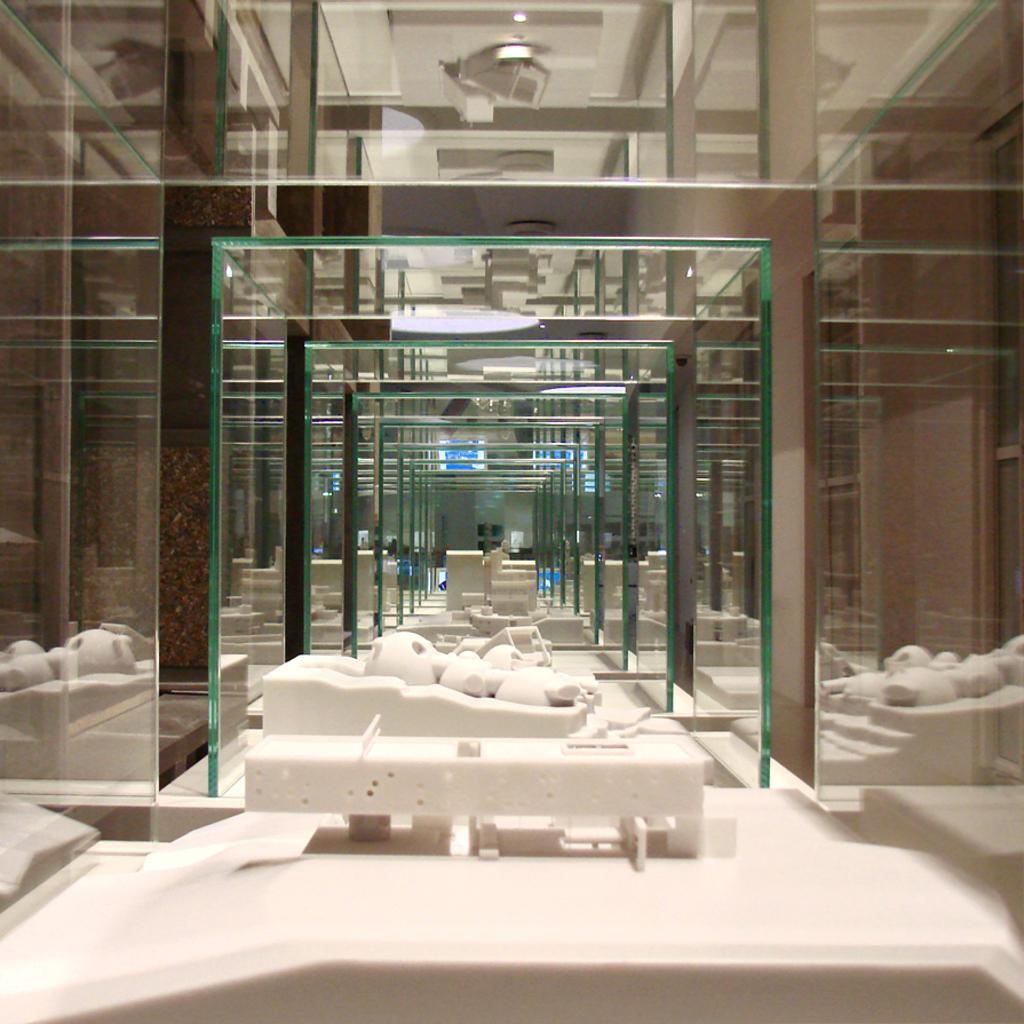Describe this image in one or two sentences. In this picture we can see some objects on the path and on the left and right side of the objects there are mirrors and other things. At the top there are ceiling lights. 